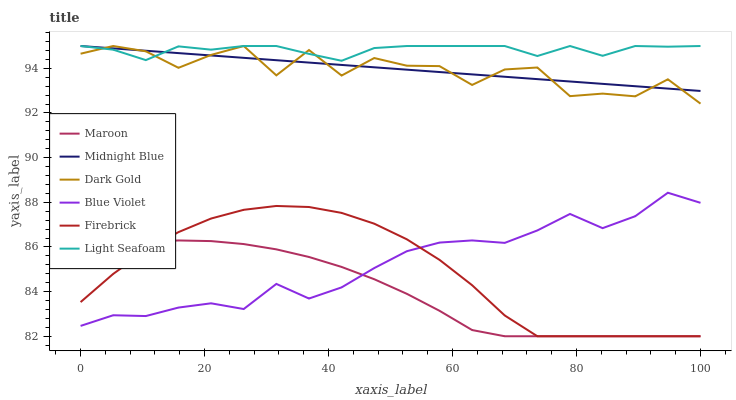Does Maroon have the minimum area under the curve?
Answer yes or no. Yes. Does Light Seafoam have the maximum area under the curve?
Answer yes or no. Yes. Does Dark Gold have the minimum area under the curve?
Answer yes or no. No. Does Dark Gold have the maximum area under the curve?
Answer yes or no. No. Is Midnight Blue the smoothest?
Answer yes or no. Yes. Is Dark Gold the roughest?
Answer yes or no. Yes. Is Firebrick the smoothest?
Answer yes or no. No. Is Firebrick the roughest?
Answer yes or no. No. Does Firebrick have the lowest value?
Answer yes or no. Yes. Does Dark Gold have the lowest value?
Answer yes or no. No. Does Light Seafoam have the highest value?
Answer yes or no. Yes. Does Firebrick have the highest value?
Answer yes or no. No. Is Firebrick less than Midnight Blue?
Answer yes or no. Yes. Is Dark Gold greater than Firebrick?
Answer yes or no. Yes. Does Light Seafoam intersect Midnight Blue?
Answer yes or no. Yes. Is Light Seafoam less than Midnight Blue?
Answer yes or no. No. Is Light Seafoam greater than Midnight Blue?
Answer yes or no. No. Does Firebrick intersect Midnight Blue?
Answer yes or no. No. 